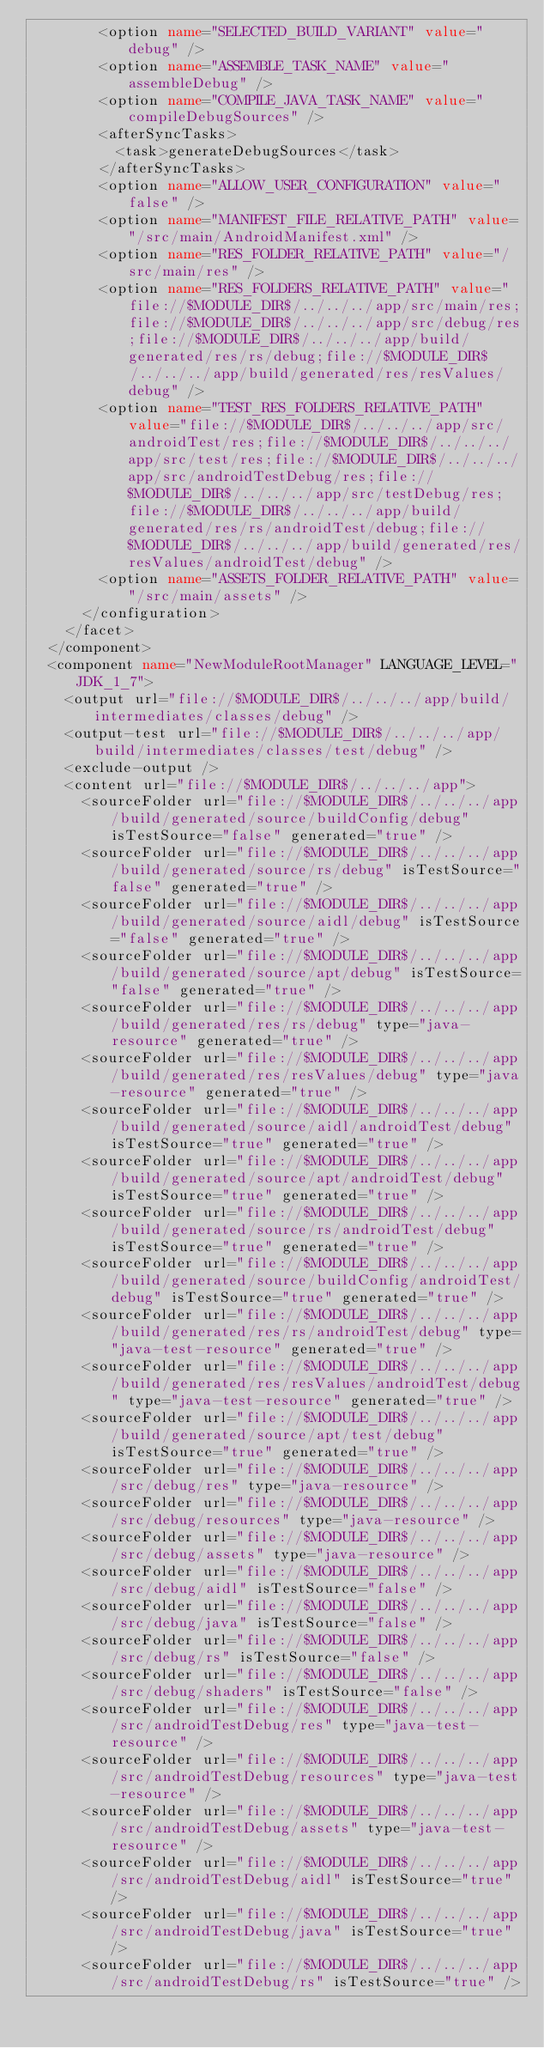<code> <loc_0><loc_0><loc_500><loc_500><_XML_>        <option name="SELECTED_BUILD_VARIANT" value="debug" />
        <option name="ASSEMBLE_TASK_NAME" value="assembleDebug" />
        <option name="COMPILE_JAVA_TASK_NAME" value="compileDebugSources" />
        <afterSyncTasks>
          <task>generateDebugSources</task>
        </afterSyncTasks>
        <option name="ALLOW_USER_CONFIGURATION" value="false" />
        <option name="MANIFEST_FILE_RELATIVE_PATH" value="/src/main/AndroidManifest.xml" />
        <option name="RES_FOLDER_RELATIVE_PATH" value="/src/main/res" />
        <option name="RES_FOLDERS_RELATIVE_PATH" value="file://$MODULE_DIR$/../../../app/src/main/res;file://$MODULE_DIR$/../../../app/src/debug/res;file://$MODULE_DIR$/../../../app/build/generated/res/rs/debug;file://$MODULE_DIR$/../../../app/build/generated/res/resValues/debug" />
        <option name="TEST_RES_FOLDERS_RELATIVE_PATH" value="file://$MODULE_DIR$/../../../app/src/androidTest/res;file://$MODULE_DIR$/../../../app/src/test/res;file://$MODULE_DIR$/../../../app/src/androidTestDebug/res;file://$MODULE_DIR$/../../../app/src/testDebug/res;file://$MODULE_DIR$/../../../app/build/generated/res/rs/androidTest/debug;file://$MODULE_DIR$/../../../app/build/generated/res/resValues/androidTest/debug" />
        <option name="ASSETS_FOLDER_RELATIVE_PATH" value="/src/main/assets" />
      </configuration>
    </facet>
  </component>
  <component name="NewModuleRootManager" LANGUAGE_LEVEL="JDK_1_7">
    <output url="file://$MODULE_DIR$/../../../app/build/intermediates/classes/debug" />
    <output-test url="file://$MODULE_DIR$/../../../app/build/intermediates/classes/test/debug" />
    <exclude-output />
    <content url="file://$MODULE_DIR$/../../../app">
      <sourceFolder url="file://$MODULE_DIR$/../../../app/build/generated/source/buildConfig/debug" isTestSource="false" generated="true" />
      <sourceFolder url="file://$MODULE_DIR$/../../../app/build/generated/source/rs/debug" isTestSource="false" generated="true" />
      <sourceFolder url="file://$MODULE_DIR$/../../../app/build/generated/source/aidl/debug" isTestSource="false" generated="true" />
      <sourceFolder url="file://$MODULE_DIR$/../../../app/build/generated/source/apt/debug" isTestSource="false" generated="true" />
      <sourceFolder url="file://$MODULE_DIR$/../../../app/build/generated/res/rs/debug" type="java-resource" generated="true" />
      <sourceFolder url="file://$MODULE_DIR$/../../../app/build/generated/res/resValues/debug" type="java-resource" generated="true" />
      <sourceFolder url="file://$MODULE_DIR$/../../../app/build/generated/source/aidl/androidTest/debug" isTestSource="true" generated="true" />
      <sourceFolder url="file://$MODULE_DIR$/../../../app/build/generated/source/apt/androidTest/debug" isTestSource="true" generated="true" />
      <sourceFolder url="file://$MODULE_DIR$/../../../app/build/generated/source/rs/androidTest/debug" isTestSource="true" generated="true" />
      <sourceFolder url="file://$MODULE_DIR$/../../../app/build/generated/source/buildConfig/androidTest/debug" isTestSource="true" generated="true" />
      <sourceFolder url="file://$MODULE_DIR$/../../../app/build/generated/res/rs/androidTest/debug" type="java-test-resource" generated="true" />
      <sourceFolder url="file://$MODULE_DIR$/../../../app/build/generated/res/resValues/androidTest/debug" type="java-test-resource" generated="true" />
      <sourceFolder url="file://$MODULE_DIR$/../../../app/build/generated/source/apt/test/debug" isTestSource="true" generated="true" />
      <sourceFolder url="file://$MODULE_DIR$/../../../app/src/debug/res" type="java-resource" />
      <sourceFolder url="file://$MODULE_DIR$/../../../app/src/debug/resources" type="java-resource" />
      <sourceFolder url="file://$MODULE_DIR$/../../../app/src/debug/assets" type="java-resource" />
      <sourceFolder url="file://$MODULE_DIR$/../../../app/src/debug/aidl" isTestSource="false" />
      <sourceFolder url="file://$MODULE_DIR$/../../../app/src/debug/java" isTestSource="false" />
      <sourceFolder url="file://$MODULE_DIR$/../../../app/src/debug/rs" isTestSource="false" />
      <sourceFolder url="file://$MODULE_DIR$/../../../app/src/debug/shaders" isTestSource="false" />
      <sourceFolder url="file://$MODULE_DIR$/../../../app/src/androidTestDebug/res" type="java-test-resource" />
      <sourceFolder url="file://$MODULE_DIR$/../../../app/src/androidTestDebug/resources" type="java-test-resource" />
      <sourceFolder url="file://$MODULE_DIR$/../../../app/src/androidTestDebug/assets" type="java-test-resource" />
      <sourceFolder url="file://$MODULE_DIR$/../../../app/src/androidTestDebug/aidl" isTestSource="true" />
      <sourceFolder url="file://$MODULE_DIR$/../../../app/src/androidTestDebug/java" isTestSource="true" />
      <sourceFolder url="file://$MODULE_DIR$/../../../app/src/androidTestDebug/rs" isTestSource="true" /></code> 